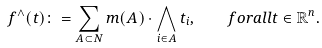Convert formula to latex. <formula><loc_0><loc_0><loc_500><loc_500>f ^ { \wedge } ( t ) \colon = \sum _ { A \subset N } m ( A ) \cdot \bigwedge _ { i \in A } t _ { i } , \quad f o r a l l t \in \mathbb { R } ^ { n } .</formula> 